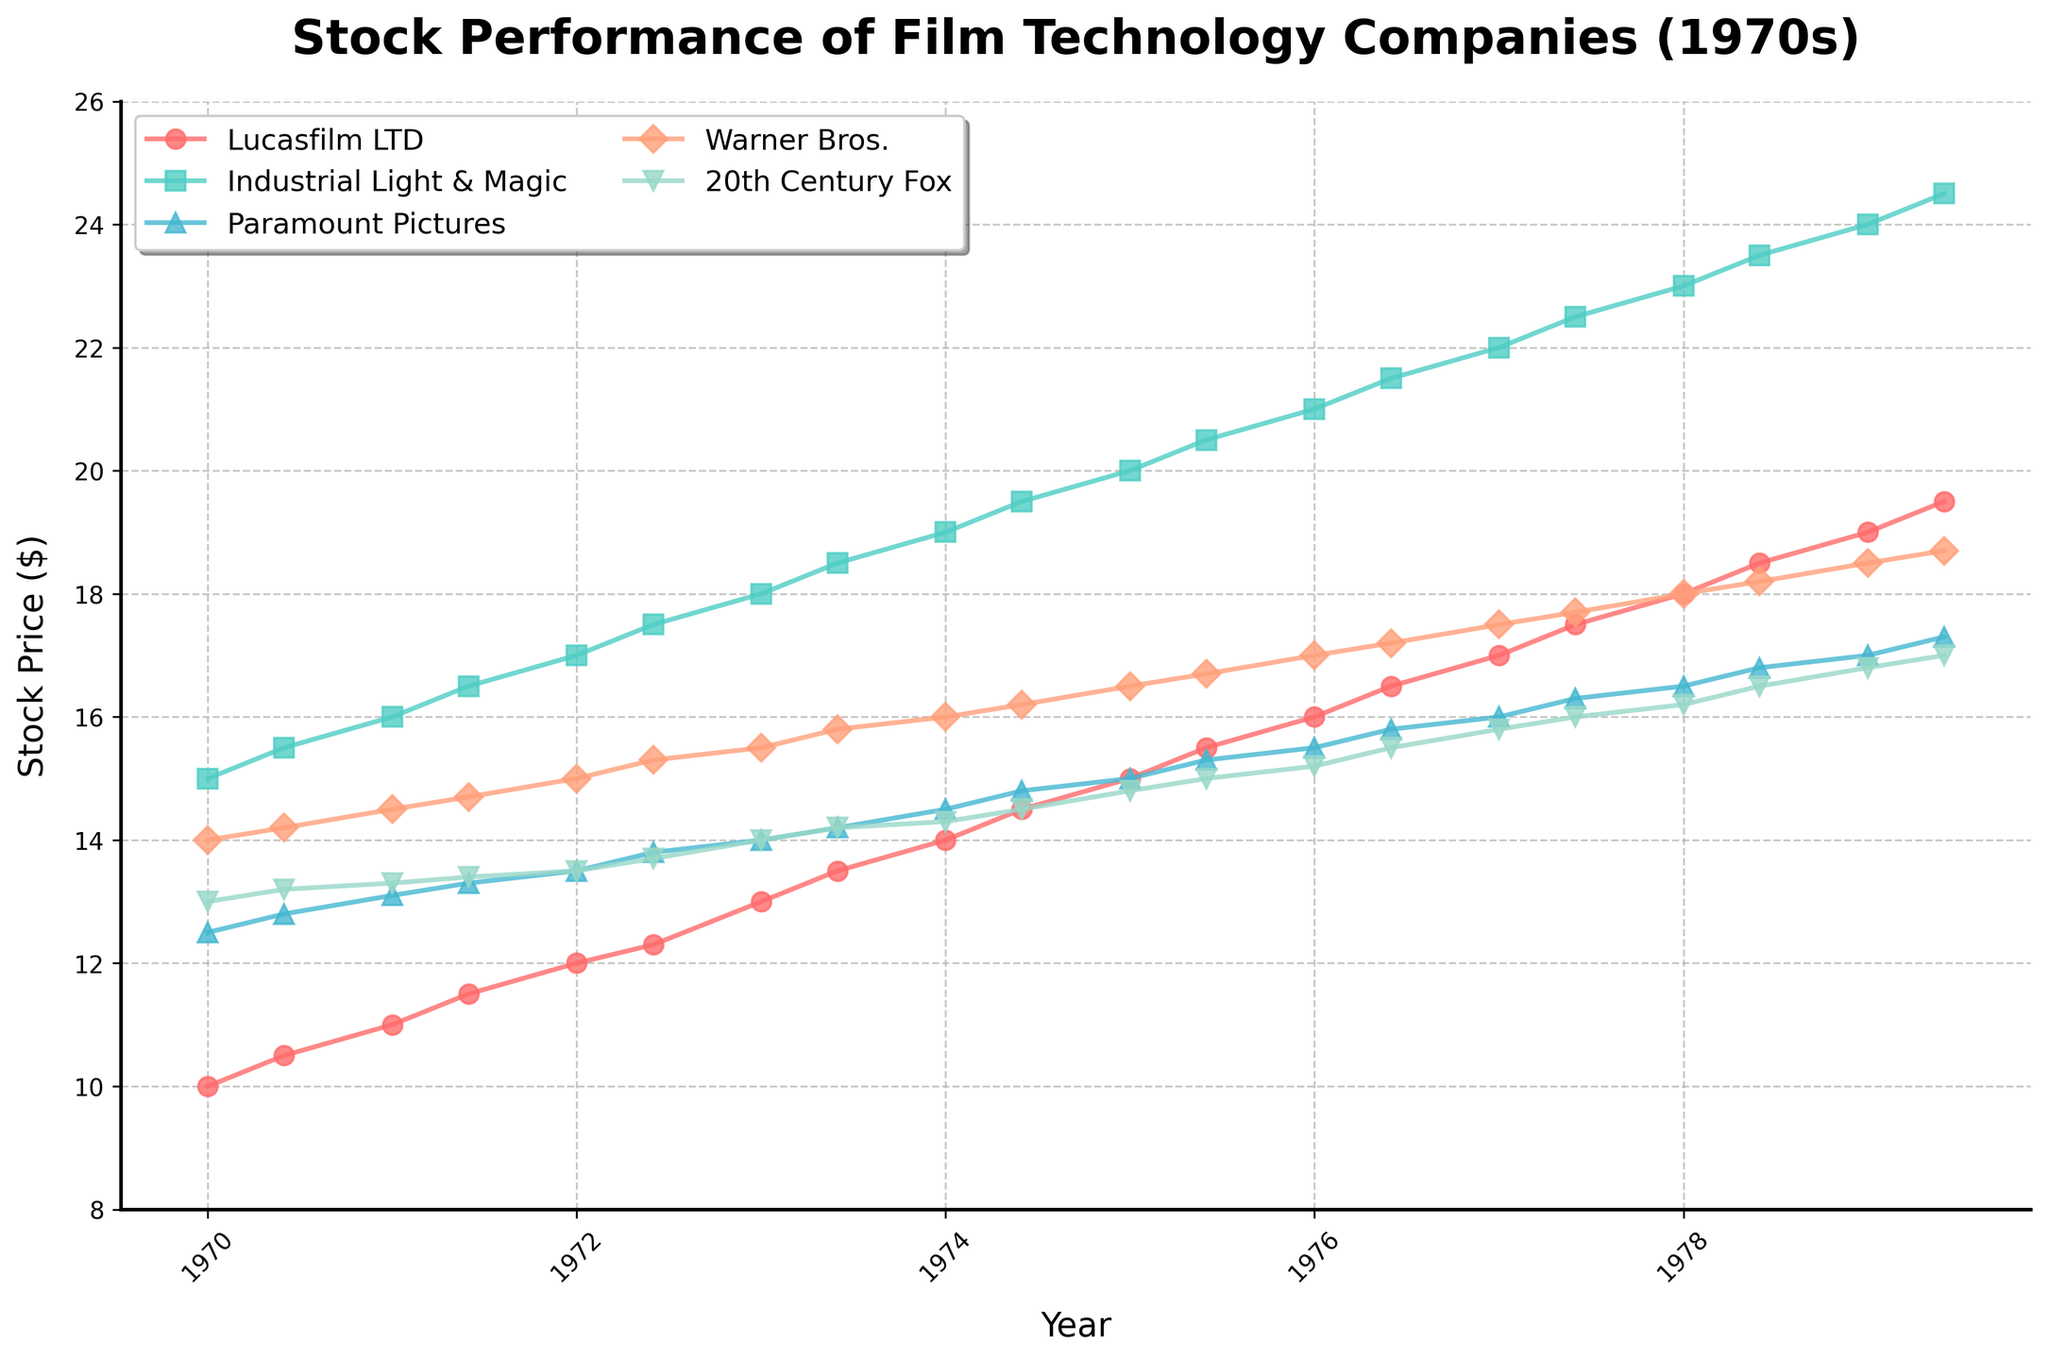What is the title of the plot? The title of the plot is displayed at the top of the figure. By reading it, we can see that it is “Stock Performance of Film Technology Companies (1970s)”.
Answer: Stock Performance of Film Technology Companies (1970s) How many companies are shown in the plot? The plot shows lines corresponding to different companies, each identified by a distinct color and marker in the legend. There are five companies listed.
Answer: 5 Which company has the highest stock price at the end of the 1970s? By looking at the plot, we can find the stock prices for each company in June 1979. The company line that reaches the highest value on the y-axis at this point is Lucasfilm LTD.
Answer: Lucasfilm LTD During which year does Lucasfilm LTD's stock price surpass $15 for the first time? By tracking the line corresponding to Lucasfilm LTD and finding where it crosses the $15 mark on the y-axis, we see this occurs in January 1975.
Answer: 1975 Whose stock price had the greatest increase over the decade? To determine this, we need to look at the initial and final values and compute the difference for each company's stock price. Lucasfilm LTD's stock price increased from $10.00 to $19.50, which is the largest increase.
Answer: Lucasfilm LTD Compare the stock price of Industrial Light & Magic and 20th Century Fox in 1973. Which one was higher and by how much? We can compare the points on the graph where the lines for Industrial Light & Magic and 20th Century Fox intersect in 1973. Industrial Light & Magic was $18.00, while 20th Century Fox was $14.00. The difference is $4.00.
Answer: Industrial Light & Magic, $4.00 What was the average stock price of Warner Bros. throughout the decade? To find the average, sum all the stock price values of Warner Bros. listed, then divide by the number of data points. The stock prices are 14.00, 14.20, 14.50, 14.70, 15.00, 15.30, 15.50, 15.80, 16.00, 16.20, 16.50, 16.70, 17.00, 17.20, 17.50, 17.70, 18.00, 18.20, 18.50, 18.70 which sum to 319.00. There are 20 data points, so 319/20 = 15.95.
Answer: 15.95 Which company showed the most steady growth throughout the decade? By observing the slopes of the lines, Lucasfilm LTD consistently increased in a nearly linear manner without significant fluctuations, indicating steady growth.
Answer: Lucasfilm LTD Consider the performance of Paramount Pictures and Warner Bros. in June 1974. Which one had a higher stock price and what's the exact difference? By examining the plotted points, we see that in June 1974, Paramount Pictures had a stock price of $14.80 and Warner Bros. had a stock price of $16.20. The difference is $1.40, with Warner Bros. being higher.
Answer: Warner Bros., $1.40 